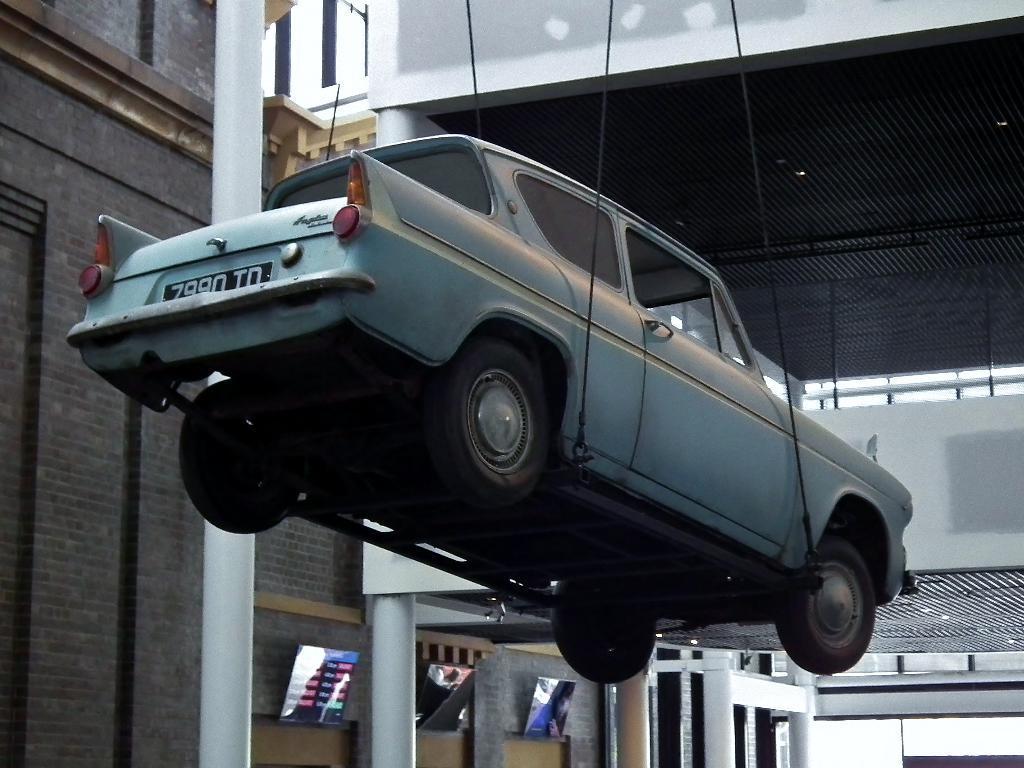Can you describe this image briefly? In this picture we can see a shed and a building, where we can see a vehicle, screens and some objects. 